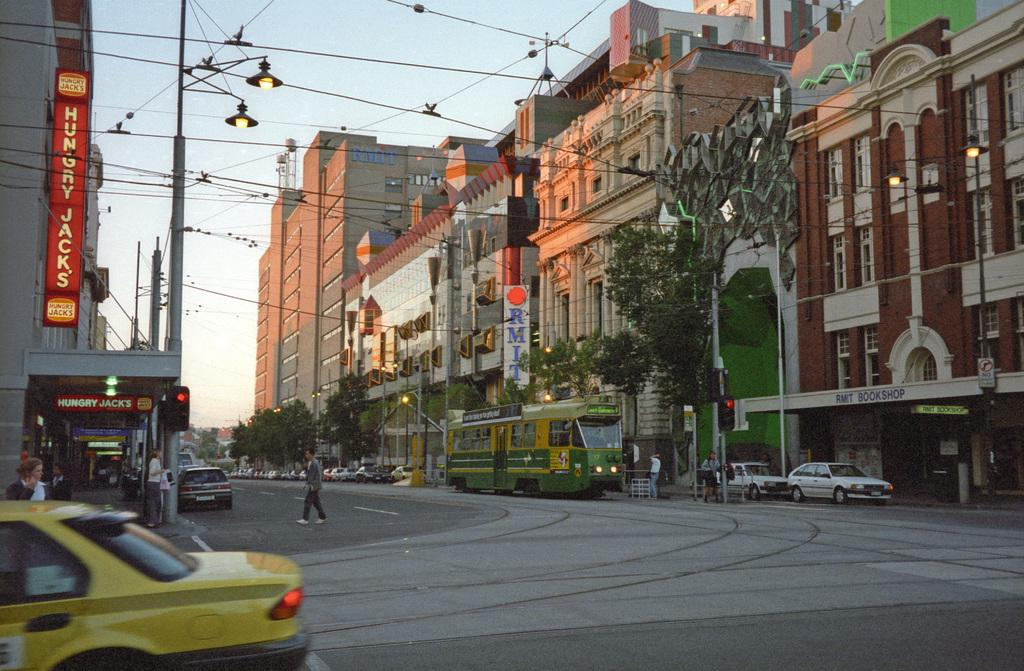<image>
Share a concise interpretation of the image provided. A city street with a banner for Hungry Jacks on the side. 